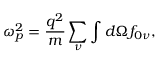<formula> <loc_0><loc_0><loc_500><loc_500>\omega _ { p } ^ { 2 } = \frac { q ^ { 2 } } { m } \sum _ { \nu } \int d \Omega f _ { 0 \nu } ,</formula> 